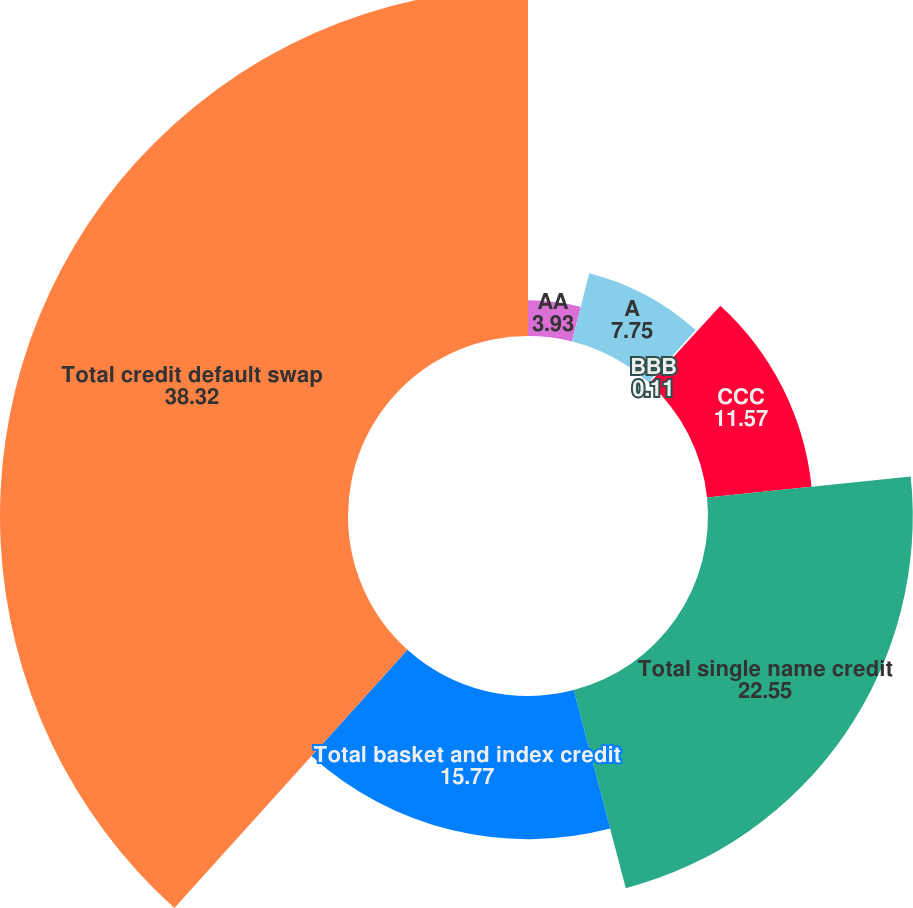Convert chart. <chart><loc_0><loc_0><loc_500><loc_500><pie_chart><fcel>AA<fcel>A<fcel>BBB<fcel>CCC<fcel>Total single name credit<fcel>Total basket and index credit<fcel>Total credit default swap<nl><fcel>3.93%<fcel>7.75%<fcel>0.11%<fcel>11.57%<fcel>22.55%<fcel>15.77%<fcel>38.32%<nl></chart> 